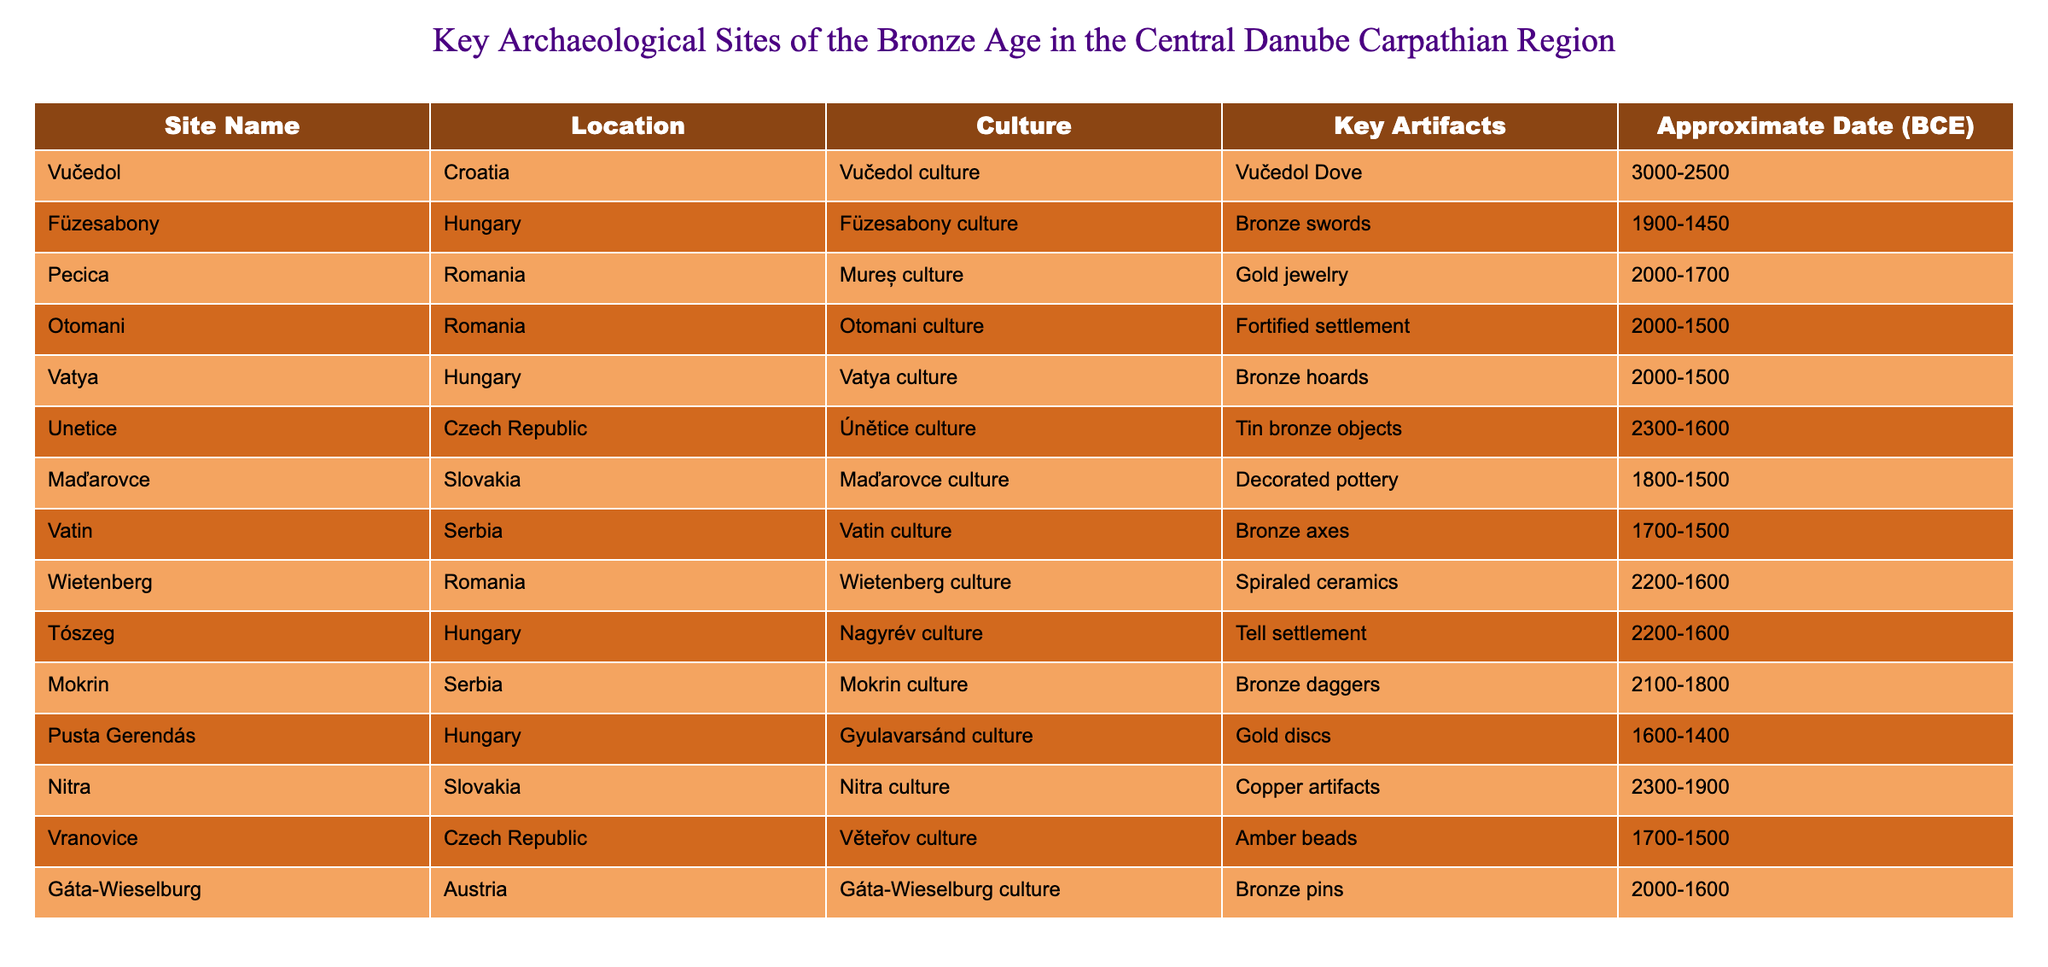What is the approximate date range of the Vučedol culture? According to the table, the Vučedol site is noted to be from 3000-2500 BCE. Therefore, the approximate date range of the Vučedol culture is 3000 to 2500 BCE.
Answer: 3000-2500 BCE Which site is associated with gold jewelry? The table indicates that the Pecica site in Romania is the one associated with gold jewelry, which is categorized under the Mureș culture.
Answer: Pecica How many sites listed date back to the period of 2000-1500 BCE? By reviewing the table, we can identify the sites that have an approximate date range of 2000-1500 BCE: Otomani, Vatya, and Pusta Gerendás. This gives us a total of three sites.
Answer: 3 Is the Furzesabony culture dated earlier than the Unetice culture? Comparing the approximate dates of both cultures in the table, Füzesabony culture (1900-1450 BCE) is indeed later than the Unetice culture (2300-1600 BCE). Thus, the statement is false.
Answer: No What is the most common artifact mentioned across these sites? A review of the table shows that there is no common artifact mentioned among different sites, as each site lists a unique artifact like the Vučedol Dove, bronze swords, gold jewelry, etc. Hence, there is no recurring artifact.
Answer: None Which culture has the oldest dating listed in the table? When examining the table, the Unetice culture dates back to 2300 BCE, making it the oldest culture listed among the key archaeological sites.
Answer: Unetice culture What is the difference in dating between the Nitra culture and the Vatya culture? The Nitra culture has an approximate dating of 2300-1900 BCE, while the Vatya culture is from 2000-1500 BCE. To find the difference, we consider the later date of Nitra, which is 1900 BCE, and Vatya, which is 1500 BCE. The difference is 1900 - 1500 = 400 years.
Answer: 400 years Are there any sites from Serbia in the table, and if so, how many? The table lists two sites from Serbia: Vatin and Mokrin. Both are confirmed to be present, thus the answer to the question is yes and there are two sites.
Answer: Yes, 2 sites Which site's artifacts are predominantly made of bronze? The sites that mention bronze artifacts include Füzesabony (bronze swords), Vatya (bronze hoards), Vatin (bronze axes), Mokrin (bronze daggers), and Unetice (tin bronze objects), hence multiple sites are associated with bronze artifacts.
Answer: Multiple sites 